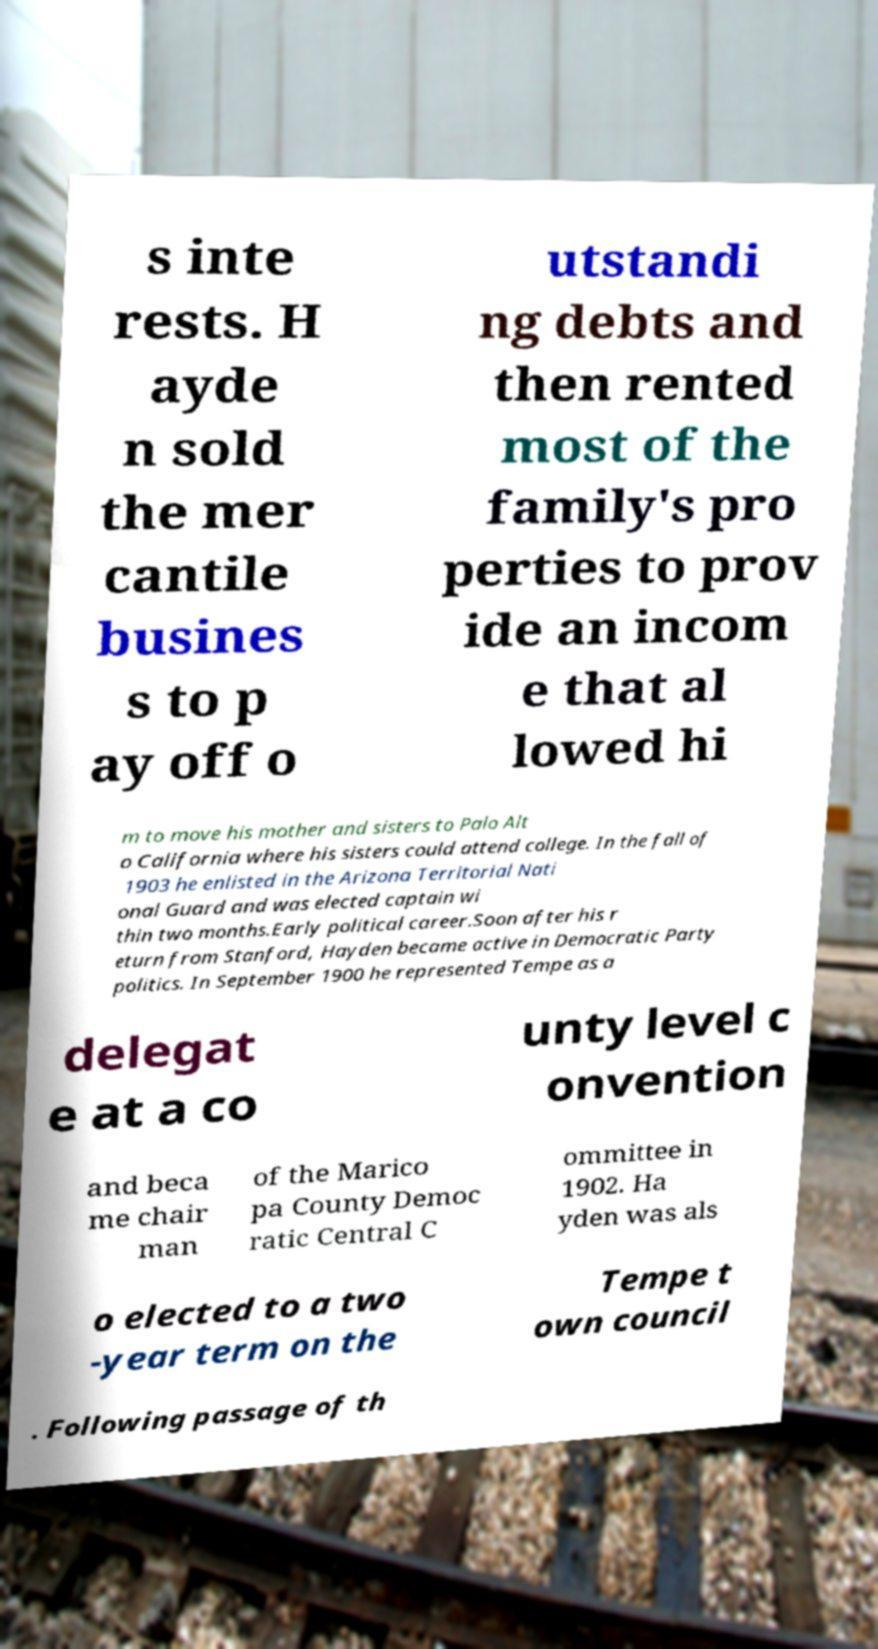Could you extract and type out the text from this image? s inte rests. H ayde n sold the mer cantile busines s to p ay off o utstandi ng debts and then rented most of the family's pro perties to prov ide an incom e that al lowed hi m to move his mother and sisters to Palo Alt o California where his sisters could attend college. In the fall of 1903 he enlisted in the Arizona Territorial Nati onal Guard and was elected captain wi thin two months.Early political career.Soon after his r eturn from Stanford, Hayden became active in Democratic Party politics. In September 1900 he represented Tempe as a delegat e at a co unty level c onvention and beca me chair man of the Marico pa County Democ ratic Central C ommittee in 1902. Ha yden was als o elected to a two -year term on the Tempe t own council . Following passage of th 